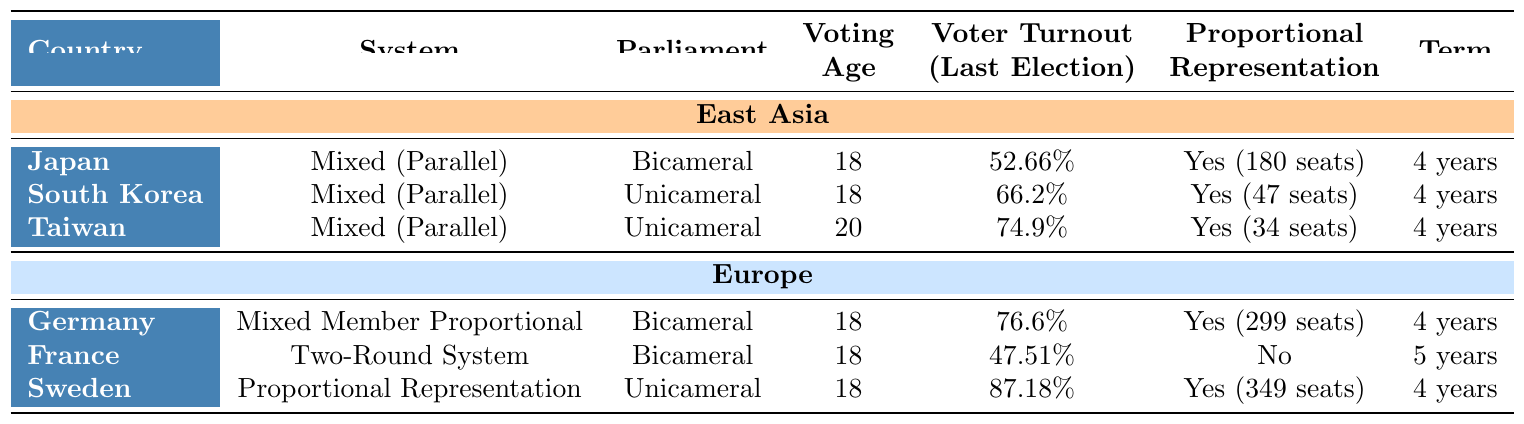What is the voting age in South Korea? The table directly states that the voting age in South Korea is 18.
Answer: 18 Which country in East Asia has the highest voter turnout? The table indicates that Taiwan has the highest voter turnout at 74.9%.
Answer: Taiwan Is Japan's electoral system a Mixed Member Proportional system? The table shows that Japan has a Mixed (Parallel) electoral system, not a Mixed Member Proportional system.
Answer: No What is the average voter turnout for East Asian countries listed? To find the average, add the voter turnout percentages: 52.66% + 66.2% + 74.9% = 193.76%. Then divide by 3 (the number of countries): 193.76 / 3 = 64.59%.
Answer: 64.59% How many countries in Europe have a bicameral parliament? The table shows that Germany, France, and Sweden are listed with bicameral parliaments. Therefore, 3 countries have a bicameral parliament.
Answer: 3 Which electoral system has the lowest voter turnout among the countries listed? From the table, France has the lowest voter turnout at 47.51%.
Answer: France Is there any country in East Asia that does not use proportional representation? The table indicates that all East Asian countries listed (Japan, South Korea, Taiwan) have proportional representation.
Answer: No What is the difference in the number of proportional representation seats between Germany and Taiwan? The table shows Germany has 299 seats and Taiwan has 34 seats. Subtracting these values gives: 299 - 34 = 265.
Answer: 265 Among the listed European countries, which has the longest term length? The table shows that France has a term length of 5 years, while the others have 4 years. Therefore, France has the longest term length.
Answer: France What is the voter turnout percentage difference between Sweden and France? Sweden's voter turnout is 87.18%, and France's is 47.51%. The difference is calculated as follows: 87.18% - 47.51% = 39.67%.
Answer: 39.67% 